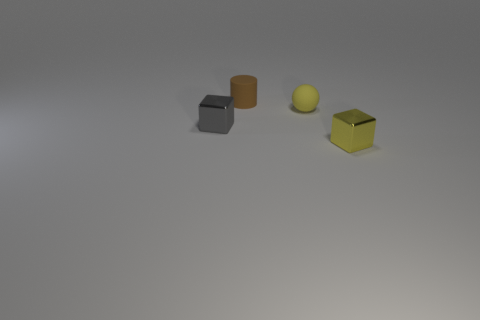Are there any tiny yellow rubber things to the right of the small cube to the left of the tiny yellow thing that is behind the gray shiny cube?
Your answer should be very brief. Yes. How big is the yellow sphere?
Give a very brief answer. Small. What number of other things are the same color as the tiny ball?
Your answer should be very brief. 1. There is a metal object behind the yellow metallic object; is its shape the same as the small yellow metal thing?
Give a very brief answer. Yes. What color is the other small metal thing that is the same shape as the tiny yellow metal thing?
Ensure brevity in your answer.  Gray. There is a yellow thing that is the same shape as the gray thing; what is its size?
Your answer should be very brief. Small. What material is the small thing that is both behind the small gray metal block and to the right of the brown rubber thing?
Ensure brevity in your answer.  Rubber. There is a tiny cube on the right side of the tiny yellow matte object; is its color the same as the sphere?
Keep it short and to the point. Yes. Does the tiny sphere have the same color as the tiny shiny cube in front of the tiny gray thing?
Offer a terse response. Yes. There is a tiny brown rubber cylinder; are there any tiny gray metal things behind it?
Your answer should be very brief. No. 